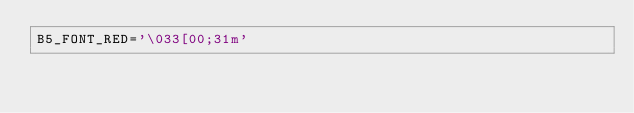<code> <loc_0><loc_0><loc_500><loc_500><_Bash_>B5_FONT_RED='\033[00;31m'</code> 